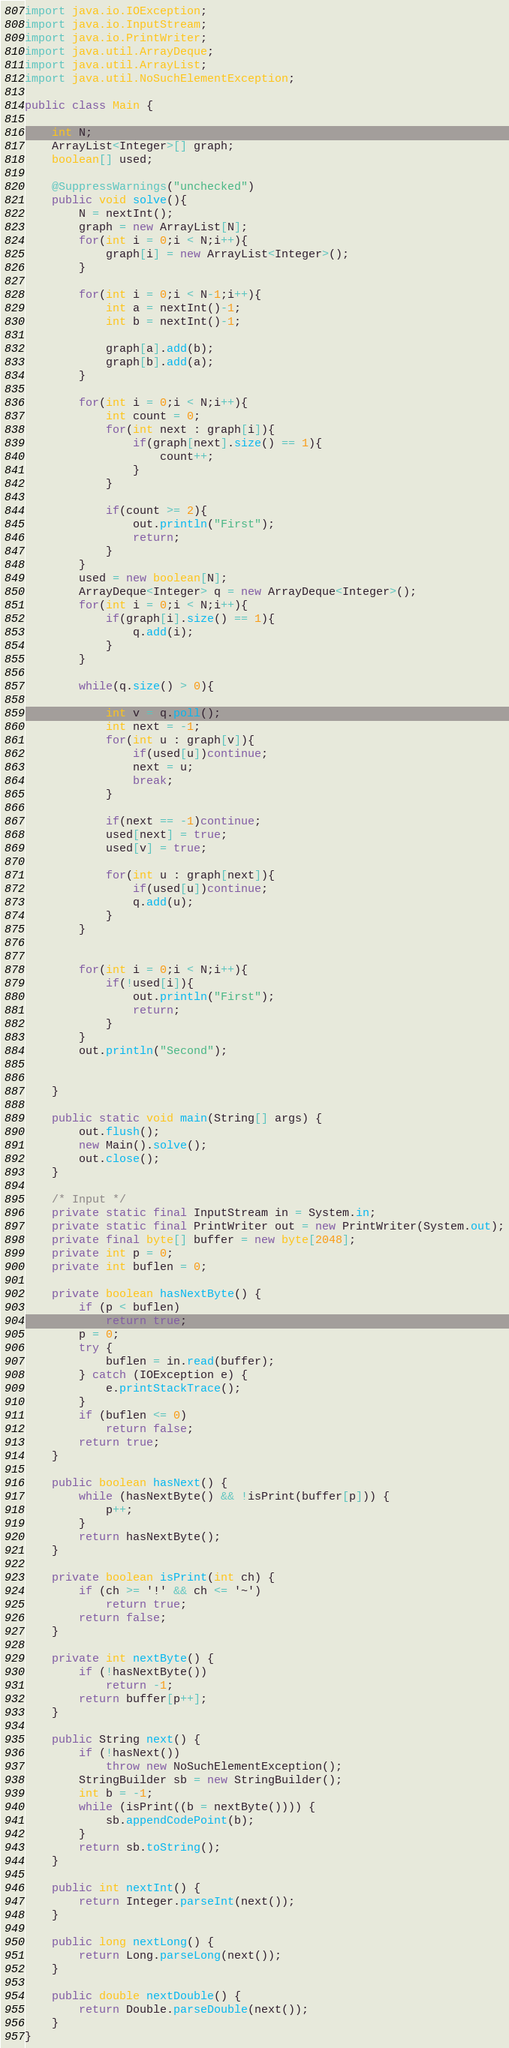<code> <loc_0><loc_0><loc_500><loc_500><_Java_>import java.io.IOException;
import java.io.InputStream;
import java.io.PrintWriter;
import java.util.ArrayDeque;
import java.util.ArrayList;
import java.util.NoSuchElementException;

public class Main {

	int N;
	ArrayList<Integer>[] graph;
	boolean[] used;

	@SuppressWarnings("unchecked")
	public void solve(){
		N = nextInt();
		graph = new ArrayList[N];
		for(int i = 0;i < N;i++){
			graph[i] = new ArrayList<Integer>();
		}

		for(int i = 0;i < N-1;i++){
			int a = nextInt()-1;
			int b = nextInt()-1;

			graph[a].add(b);
			graph[b].add(a);
		}

		for(int i = 0;i < N;i++){
			int count = 0;
			for(int next : graph[i]){
				if(graph[next].size() == 1){
					count++;
				}
			}

			if(count >= 2){
				out.println("First");
				return;
			}
		}
		used = new boolean[N];
		ArrayDeque<Integer> q = new ArrayDeque<Integer>();
		for(int i = 0;i < N;i++){
			if(graph[i].size() == 1){
				q.add(i);
			}
		}

		while(q.size() > 0){

			int v = q.poll();
			int next = -1;
			for(int u : graph[v]){
				if(used[u])continue;
				next = u;
				break;
			}

			if(next == -1)continue;
			used[next] = true;
			used[v] = true;

			for(int u : graph[next]){
				if(used[u])continue;
				q.add(u);
			}
		}


		for(int i = 0;i < N;i++){
			if(!used[i]){
				out.println("First");
				return;
			}
		}
		out.println("Second");


	}

	public static void main(String[] args) {
		out.flush();
		new Main().solve();
		out.close();
	}

	/* Input */
	private static final InputStream in = System.in;
	private static final PrintWriter out = new PrintWriter(System.out);
	private final byte[] buffer = new byte[2048];
	private int p = 0;
	private int buflen = 0;

	private boolean hasNextByte() {
		if (p < buflen)
			return true;
		p = 0;
		try {
			buflen = in.read(buffer);
		} catch (IOException e) {
			e.printStackTrace();
		}
		if (buflen <= 0)
			return false;
		return true;
	}

	public boolean hasNext() {
		while (hasNextByte() && !isPrint(buffer[p])) {
			p++;
		}
		return hasNextByte();
	}

	private boolean isPrint(int ch) {
		if (ch >= '!' && ch <= '~')
			return true;
		return false;
	}

	private int nextByte() {
		if (!hasNextByte())
			return -1;
		return buffer[p++];
	}

	public String next() {
		if (!hasNext())
			throw new NoSuchElementException();
		StringBuilder sb = new StringBuilder();
		int b = -1;
		while (isPrint((b = nextByte()))) {
			sb.appendCodePoint(b);
		}
		return sb.toString();
	}

	public int nextInt() {
		return Integer.parseInt(next());
	}

	public long nextLong() {
		return Long.parseLong(next());
	}

	public double nextDouble() {
		return Double.parseDouble(next());
	}
}</code> 